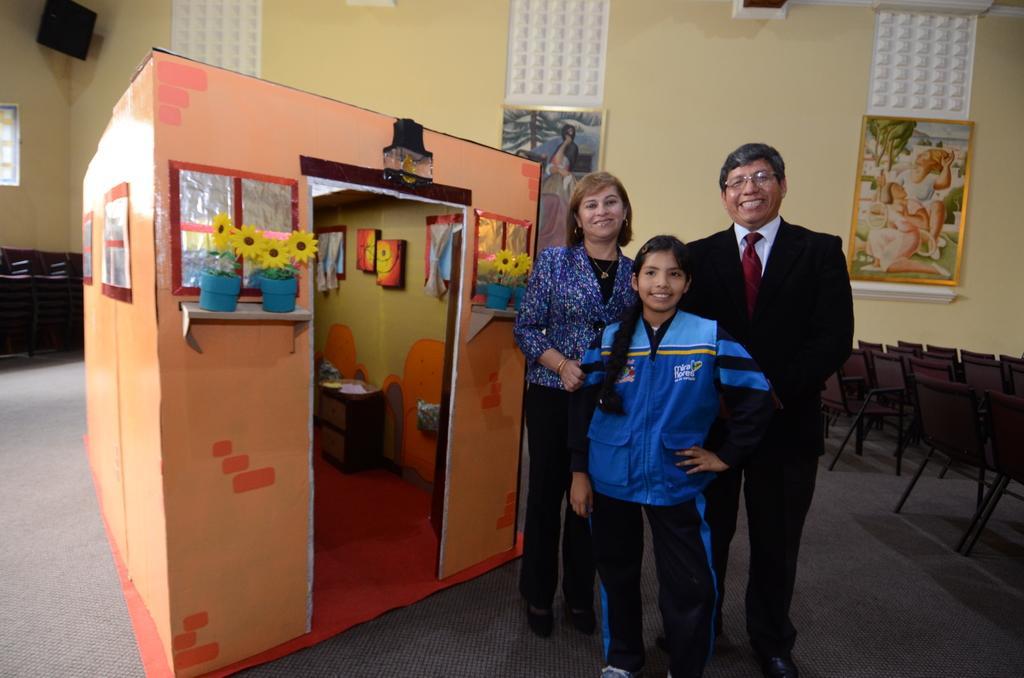In one or two sentences, can you explain what this image depicts? In the center of the image we can see three people standing and smiling. On the right there are chairs. On the left we can see a shed. In the background there is a wall and we can see wall frames placed on the wall. 